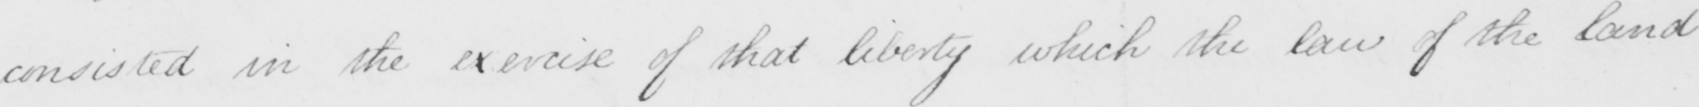Please transcribe the handwritten text in this image. consisted in the exercise of that liberty which the law of the land 